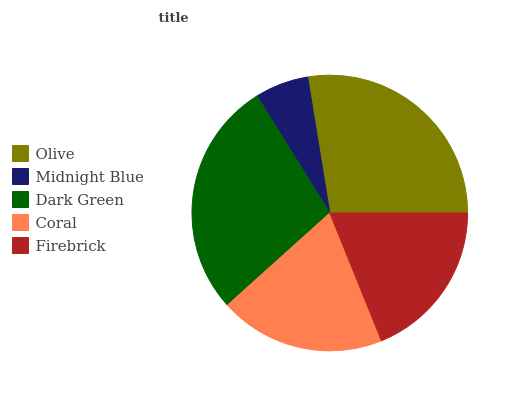Is Midnight Blue the minimum?
Answer yes or no. Yes. Is Dark Green the maximum?
Answer yes or no. Yes. Is Dark Green the minimum?
Answer yes or no. No. Is Midnight Blue the maximum?
Answer yes or no. No. Is Dark Green greater than Midnight Blue?
Answer yes or no. Yes. Is Midnight Blue less than Dark Green?
Answer yes or no. Yes. Is Midnight Blue greater than Dark Green?
Answer yes or no. No. Is Dark Green less than Midnight Blue?
Answer yes or no. No. Is Coral the high median?
Answer yes or no. Yes. Is Coral the low median?
Answer yes or no. Yes. Is Firebrick the high median?
Answer yes or no. No. Is Midnight Blue the low median?
Answer yes or no. No. 